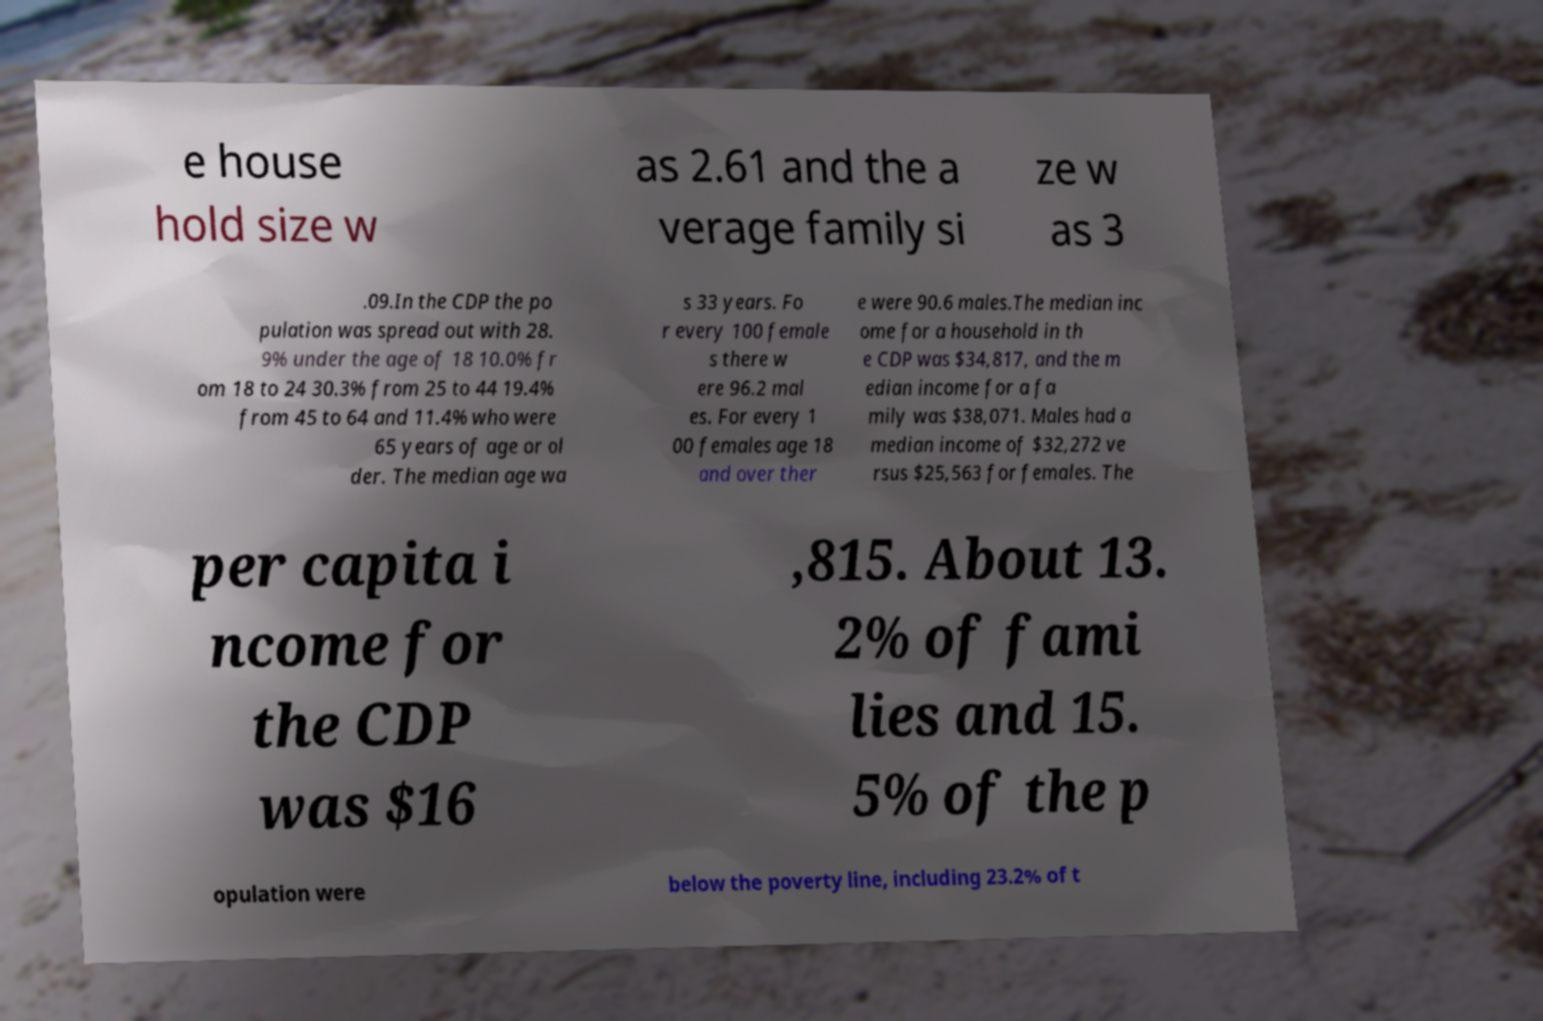Could you extract and type out the text from this image? e house hold size w as 2.61 and the a verage family si ze w as 3 .09.In the CDP the po pulation was spread out with 28. 9% under the age of 18 10.0% fr om 18 to 24 30.3% from 25 to 44 19.4% from 45 to 64 and 11.4% who were 65 years of age or ol der. The median age wa s 33 years. Fo r every 100 female s there w ere 96.2 mal es. For every 1 00 females age 18 and over ther e were 90.6 males.The median inc ome for a household in th e CDP was $34,817, and the m edian income for a fa mily was $38,071. Males had a median income of $32,272 ve rsus $25,563 for females. The per capita i ncome for the CDP was $16 ,815. About 13. 2% of fami lies and 15. 5% of the p opulation were below the poverty line, including 23.2% of t 